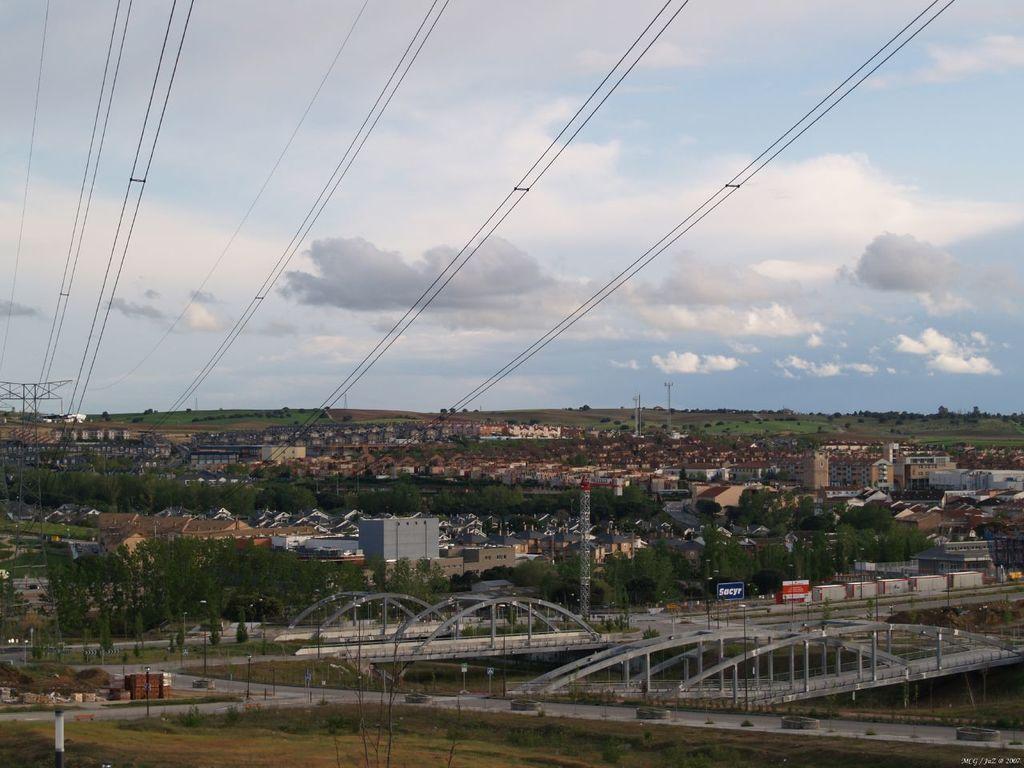How would you summarize this image in a sentence or two? In this picture there is a view of the town with metal bridges, some buildings and small houses. Above there are some cables with electric tower. 